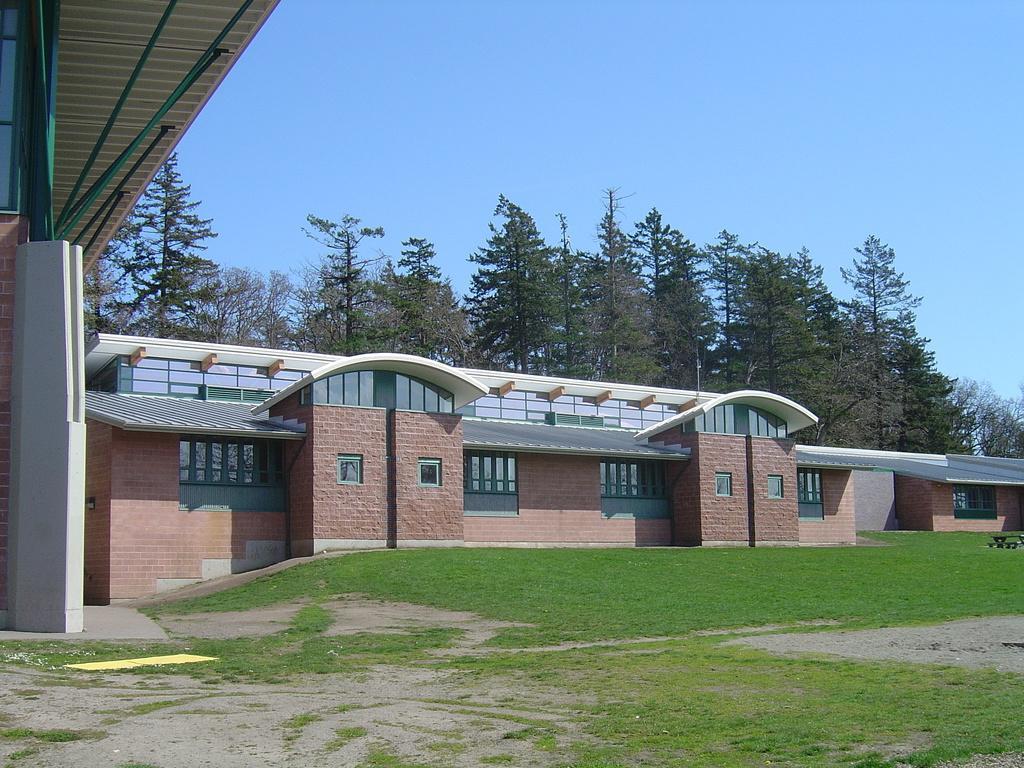Can you describe this image briefly? In the center of the image there is a building. At the bottom of the image there is grass. In the background we can see trees and sky. 